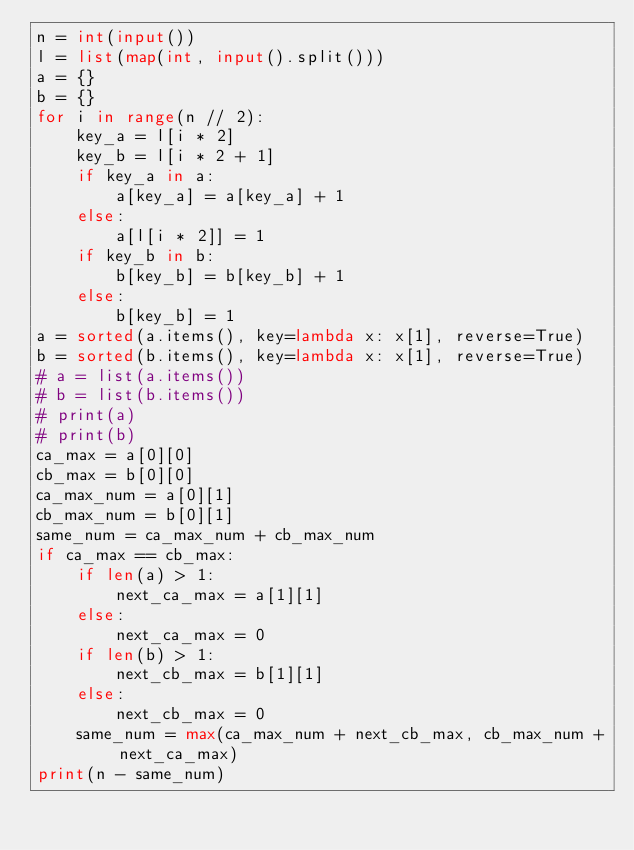<code> <loc_0><loc_0><loc_500><loc_500><_Python_>n = int(input())
l = list(map(int, input().split()))
a = {}
b = {}
for i in range(n // 2):
    key_a = l[i * 2]
    key_b = l[i * 2 + 1]
    if key_a in a:
        a[key_a] = a[key_a] + 1
    else:
        a[l[i * 2]] = 1
    if key_b in b:
        b[key_b] = b[key_b] + 1
    else:
        b[key_b] = 1
a = sorted(a.items(), key=lambda x: x[1], reverse=True)
b = sorted(b.items(), key=lambda x: x[1], reverse=True)
# a = list(a.items())
# b = list(b.items())
# print(a)
# print(b)
ca_max = a[0][0]
cb_max = b[0][0]
ca_max_num = a[0][1]
cb_max_num = b[0][1]
same_num = ca_max_num + cb_max_num
if ca_max == cb_max:
    if len(a) > 1:
        next_ca_max = a[1][1]
    else:
        next_ca_max = 0
    if len(b) > 1:
        next_cb_max = b[1][1]
    else:
        next_cb_max = 0
    same_num = max(ca_max_num + next_cb_max, cb_max_num + next_ca_max)
print(n - same_num)</code> 